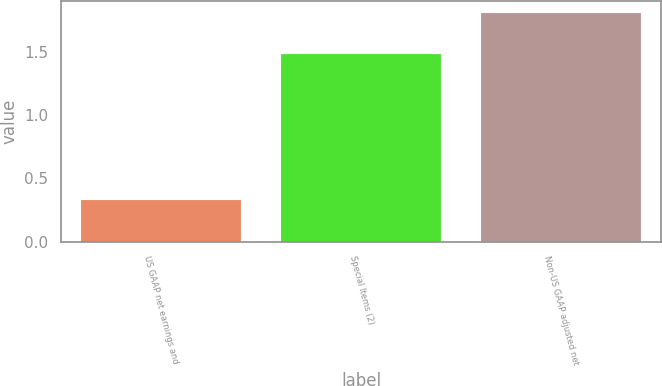<chart> <loc_0><loc_0><loc_500><loc_500><bar_chart><fcel>US GAAP net earnings and<fcel>Special Items (2)<fcel>Non-US GAAP adjusted net<nl><fcel>0.33<fcel>1.48<fcel>1.81<nl></chart> 